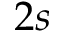Convert formula to latex. <formula><loc_0><loc_0><loc_500><loc_500>2 s</formula> 